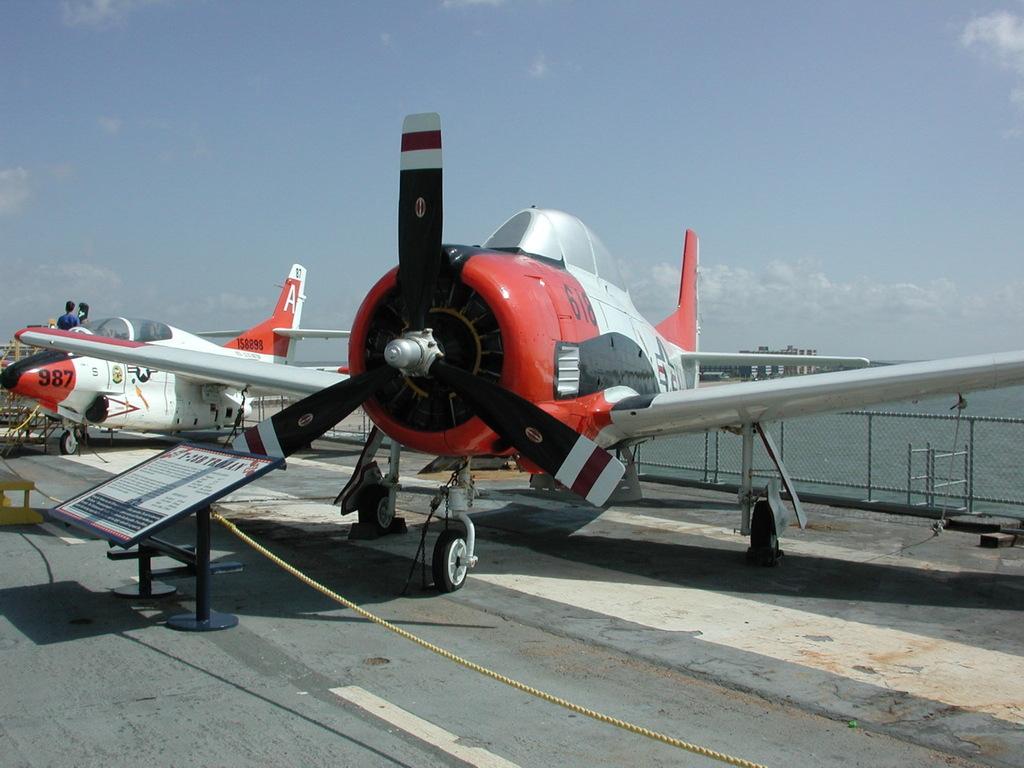What letter is written on the side of the red propeller plane?
Provide a short and direct response. Unanswerable. What 3 digit number is on the plane in the back?
Offer a terse response. 987. 